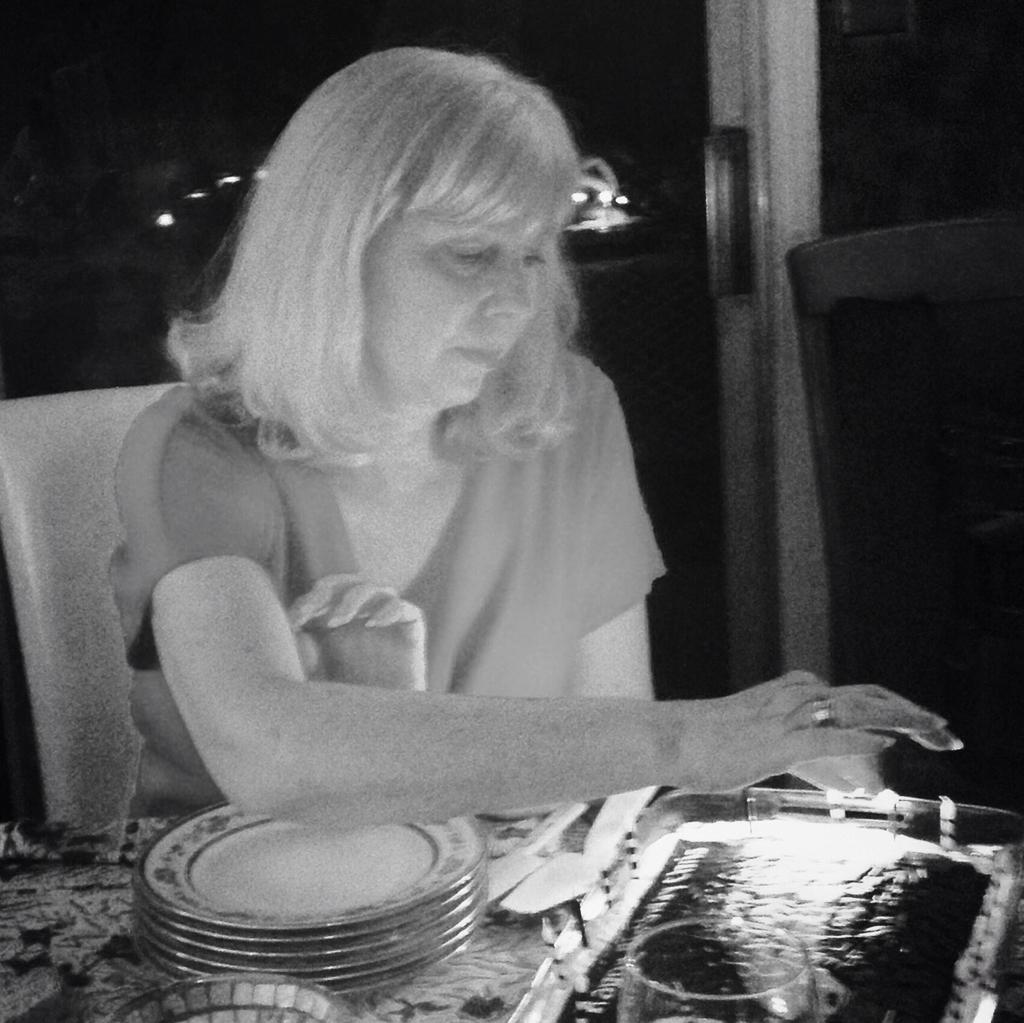What is the person in the image doing? There is a person sitting in the image. What objects are on the table in the image? There are plates, a tray, and glasses on the table in the image. What can be seen in the background of the image? The background of the image includes a glass door. How is the image presented in terms of color? The image is in black and white. Is the person wearing a crown in the image? There is no crown visible in the image. How many points does the person have on their head in the image? The person does not have any points on their head in the image. 